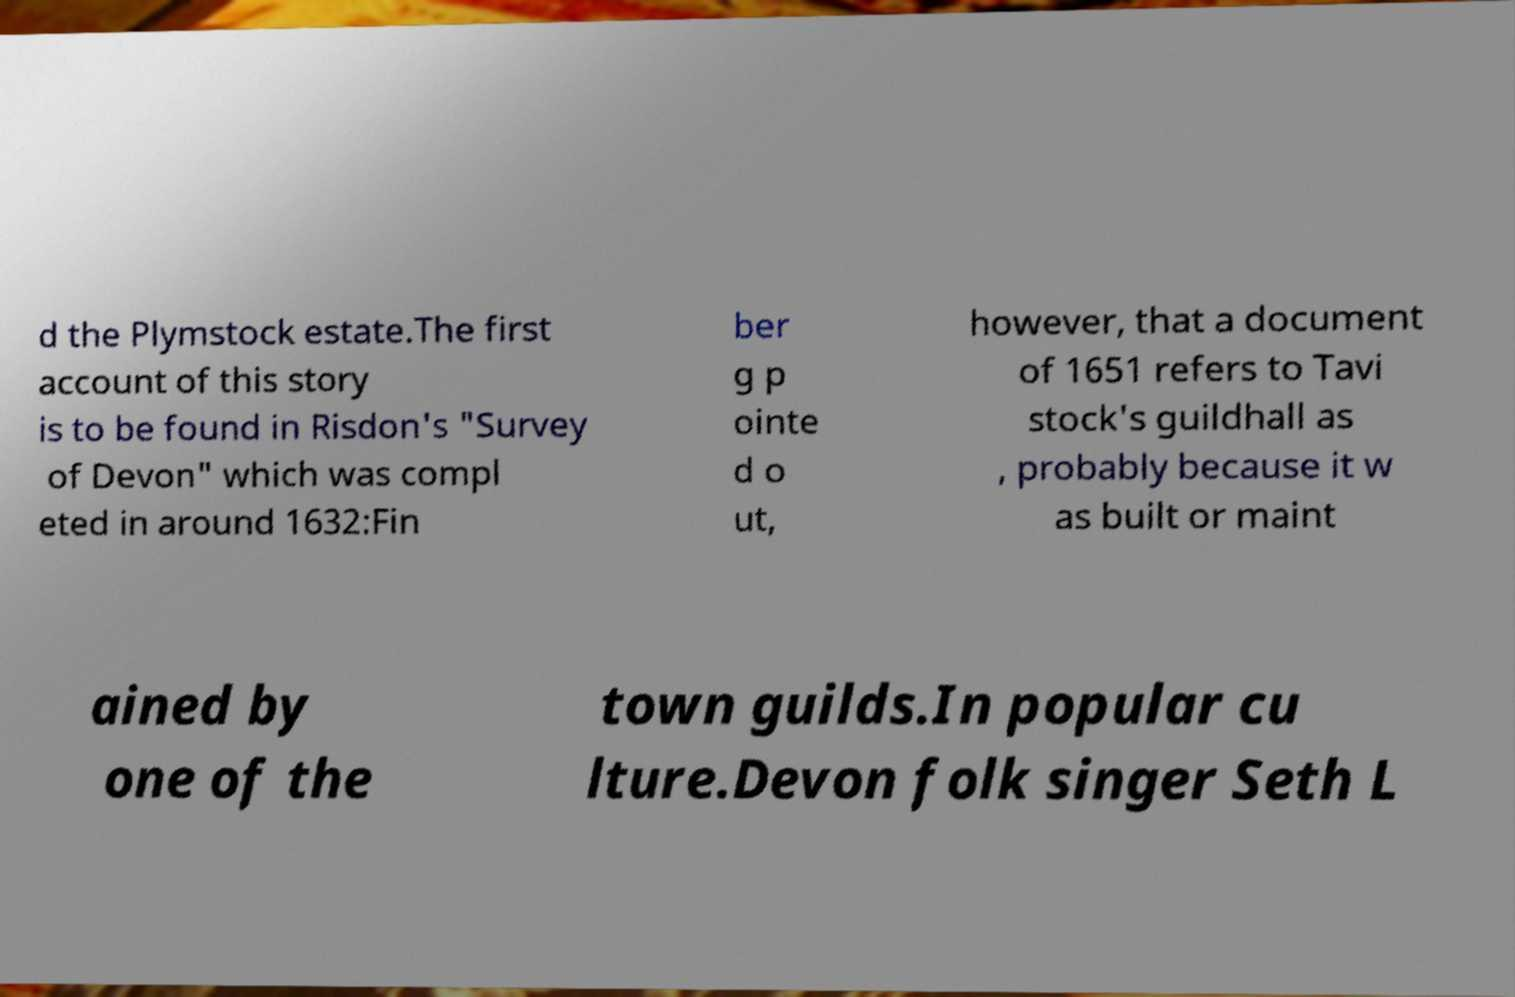What messages or text are displayed in this image? I need them in a readable, typed format. d the Plymstock estate.The first account of this story is to be found in Risdon's "Survey of Devon" which was compl eted in around 1632:Fin ber g p ointe d o ut, however, that a document of 1651 refers to Tavi stock's guildhall as , probably because it w as built or maint ained by one of the town guilds.In popular cu lture.Devon folk singer Seth L 